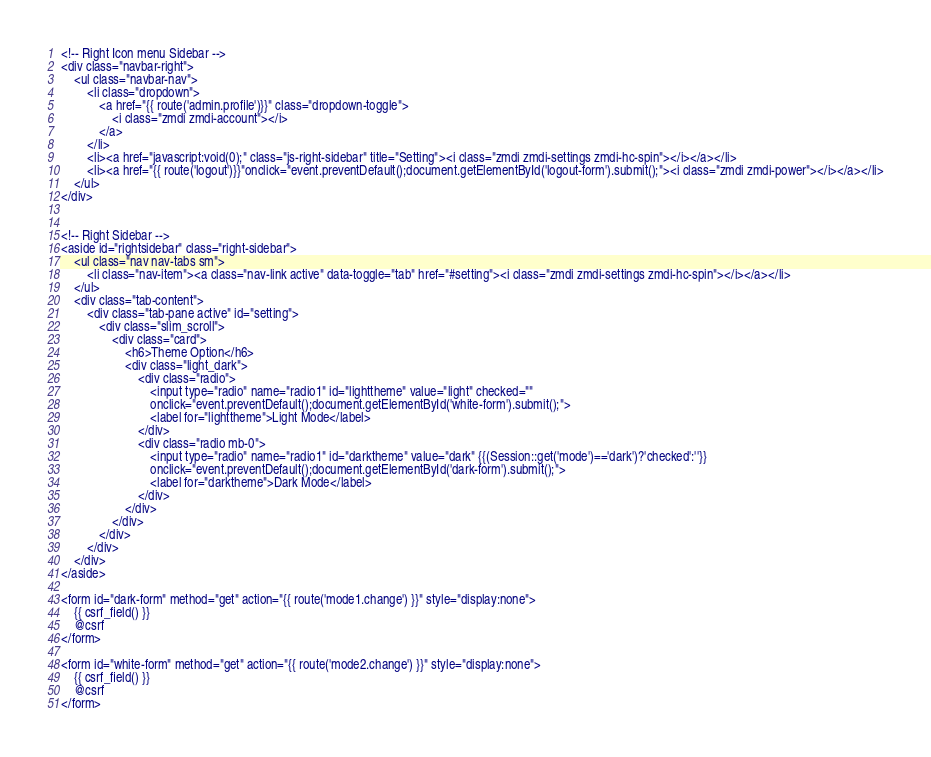<code> <loc_0><loc_0><loc_500><loc_500><_PHP_><!-- Right Icon menu Sidebar -->
<div class="navbar-right">
    <ul class="navbar-nav">
        <li class="dropdown">
            <a href="{{ route('admin.profile')}}" class="dropdown-toggle">
                <i class="zmdi zmdi-account"></i>
            </a>
        </li>
        <li><a href="javascript:void(0);" class="js-right-sidebar" title="Setting"><i class="zmdi zmdi-settings zmdi-hc-spin"></i></a></li>
        <li><a href="{{ route('logout')}}"onclick="event.preventDefault();document.getElementById('logout-form').submit();"><i class="zmdi zmdi-power"></i></a></li>
    </ul>
</div>


<!-- Right Sidebar -->
<aside id="rightsidebar" class="right-sidebar">
    <ul class="nav nav-tabs sm">
        <li class="nav-item"><a class="nav-link active" data-toggle="tab" href="#setting"><i class="zmdi zmdi-settings zmdi-hc-spin"></i></a></li>
    </ul>
    <div class="tab-content">
        <div class="tab-pane active" id="setting">
            <div class="slim_scroll">
                <div class="card">
                    <h6>Theme Option</h6>
                    <div class="light_dark">
                        <div class="radio">
                            <input type="radio" name="radio1" id="lighttheme" value="light" checked=""
                            onclick="event.preventDefault();document.getElementById('white-form').submit();">
                            <label for="lighttheme">Light Mode</label>
                        </div>
                        <div class="radio mb-0">
                            <input type="radio" name="radio1" id="darktheme" value="dark" {{(Session::get('mode')=='dark')?'checked':''}} 
                            onclick="event.preventDefault();document.getElementById('dark-form').submit();">
                            <label for="darktheme">Dark Mode</label>
                        </div>
                    </div>
                </div>               
            </div>                
        </div>
    </div>
</aside>

<form id="dark-form" method="get" action="{{ route('mode1.change') }}" style="display:none">
    {{ csrf_field() }}
    @csrf
</form>

<form id="white-form" method="get" action="{{ route('mode2.change') }}" style="display:none">
    {{ csrf_field() }}
    @csrf
</form></code> 